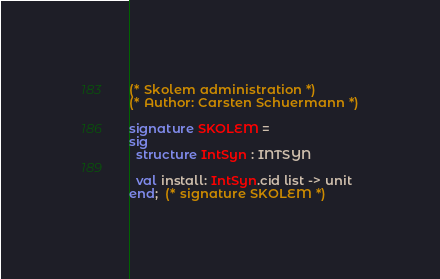<code> <loc_0><loc_0><loc_500><loc_500><_SML_>(* Skolem administration *)
(* Author: Carsten Schuermann *)

signature SKOLEM =
sig
  structure IntSyn : INTSYN

  val install: IntSyn.cid list -> unit
end;  (* signature SKOLEM *)
</code> 